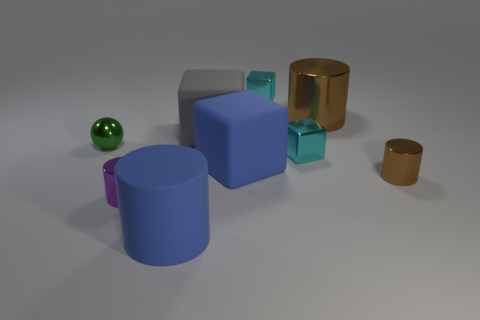How many things are big gray spheres or small green shiny balls?
Your answer should be very brief. 1. What size is the rubber thing that is the same color as the big rubber cylinder?
Give a very brief answer. Large. Are there any tiny purple cylinders to the left of the green metallic sphere?
Keep it short and to the point. No. Are there more large gray matte cubes that are on the right side of the gray cube than tiny brown objects left of the small green metal sphere?
Provide a succinct answer. No. What is the size of the purple metallic object that is the same shape as the small brown object?
Offer a very short reply. Small. What number of cubes are either big brown shiny things or big blue objects?
Your answer should be compact. 1. What is the material of the tiny cylinder that is the same color as the large shiny object?
Ensure brevity in your answer.  Metal. Are there fewer large brown things that are left of the green object than green objects right of the gray matte object?
Keep it short and to the point. No. How many things are tiny objects that are to the right of the tiny green metallic object or big blue metal balls?
Keep it short and to the point. 4. There is a cyan metallic thing right of the cyan metallic object that is behind the big brown metal cylinder; what shape is it?
Ensure brevity in your answer.  Cube. 